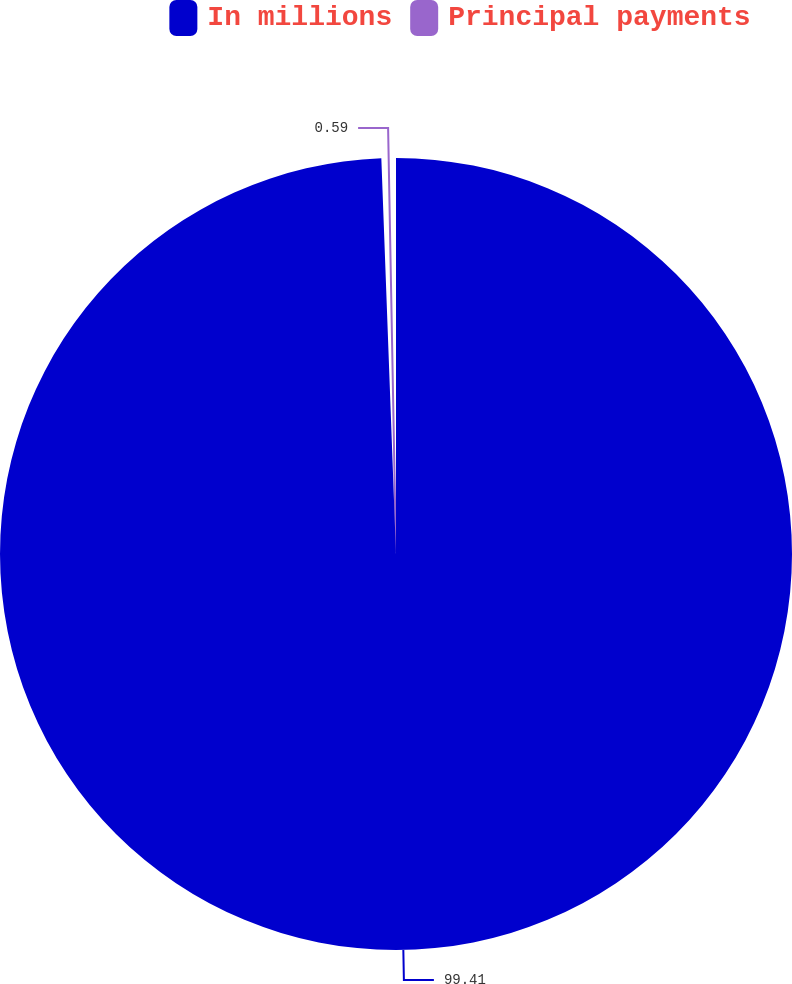Convert chart. <chart><loc_0><loc_0><loc_500><loc_500><pie_chart><fcel>In millions<fcel>Principal payments<nl><fcel>99.41%<fcel>0.59%<nl></chart> 